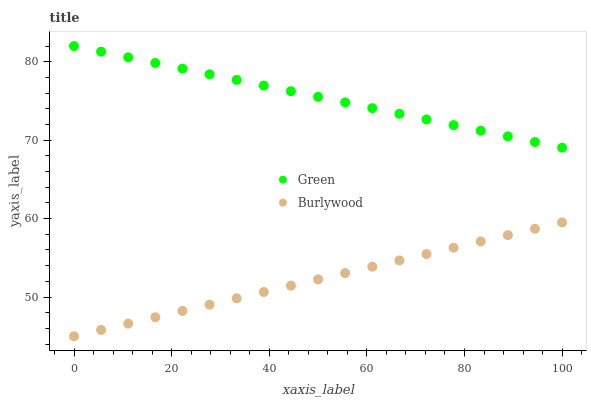Does Burlywood have the minimum area under the curve?
Answer yes or no. Yes. Does Green have the maximum area under the curve?
Answer yes or no. Yes. Does Green have the minimum area under the curve?
Answer yes or no. No. Is Burlywood the smoothest?
Answer yes or no. Yes. Is Green the roughest?
Answer yes or no. Yes. Is Green the smoothest?
Answer yes or no. No. Does Burlywood have the lowest value?
Answer yes or no. Yes. Does Green have the lowest value?
Answer yes or no. No. Does Green have the highest value?
Answer yes or no. Yes. Is Burlywood less than Green?
Answer yes or no. Yes. Is Green greater than Burlywood?
Answer yes or no. Yes. Does Burlywood intersect Green?
Answer yes or no. No. 